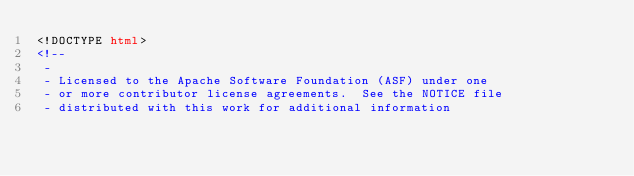<code> <loc_0><loc_0><loc_500><loc_500><_HTML_><!DOCTYPE html>
<!--
 -
 - Licensed to the Apache Software Foundation (ASF) under one
 - or more contributor license agreements.  See the NOTICE file
 - distributed with this work for additional information</code> 